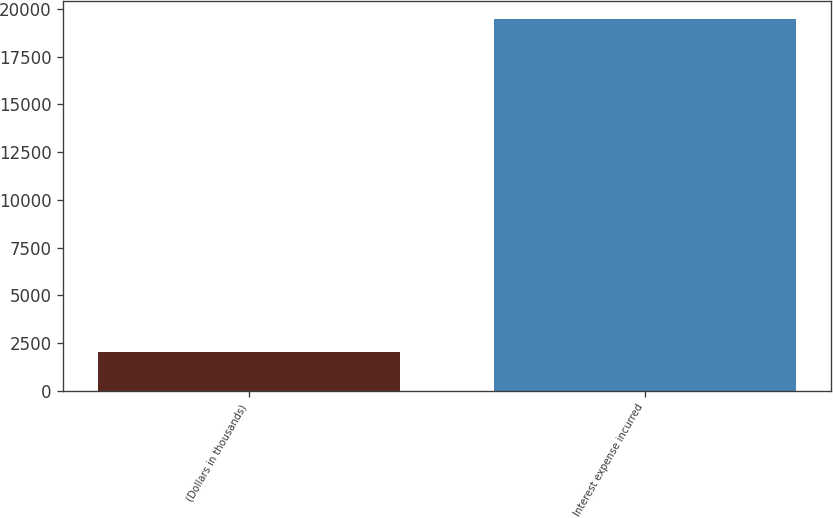<chart> <loc_0><loc_0><loc_500><loc_500><bar_chart><fcel>(Dollars in thousands)<fcel>Interest expense incurred<nl><fcel>2016<fcel>19472<nl></chart> 